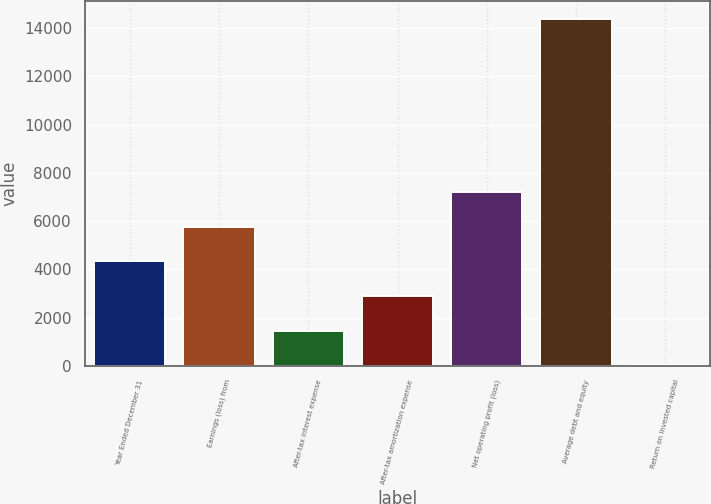Convert chart. <chart><loc_0><loc_0><loc_500><loc_500><bar_chart><fcel>Year Ended December 31<fcel>Earnings (loss) from<fcel>After-tax interest expense<fcel>After-tax amortization expense<fcel>Net operating profit (loss)<fcel>Average debt and equity<fcel>Return on invested capital<nl><fcel>4329.95<fcel>5767.1<fcel>1455.65<fcel>2892.8<fcel>7204.25<fcel>14390<fcel>18.5<nl></chart> 